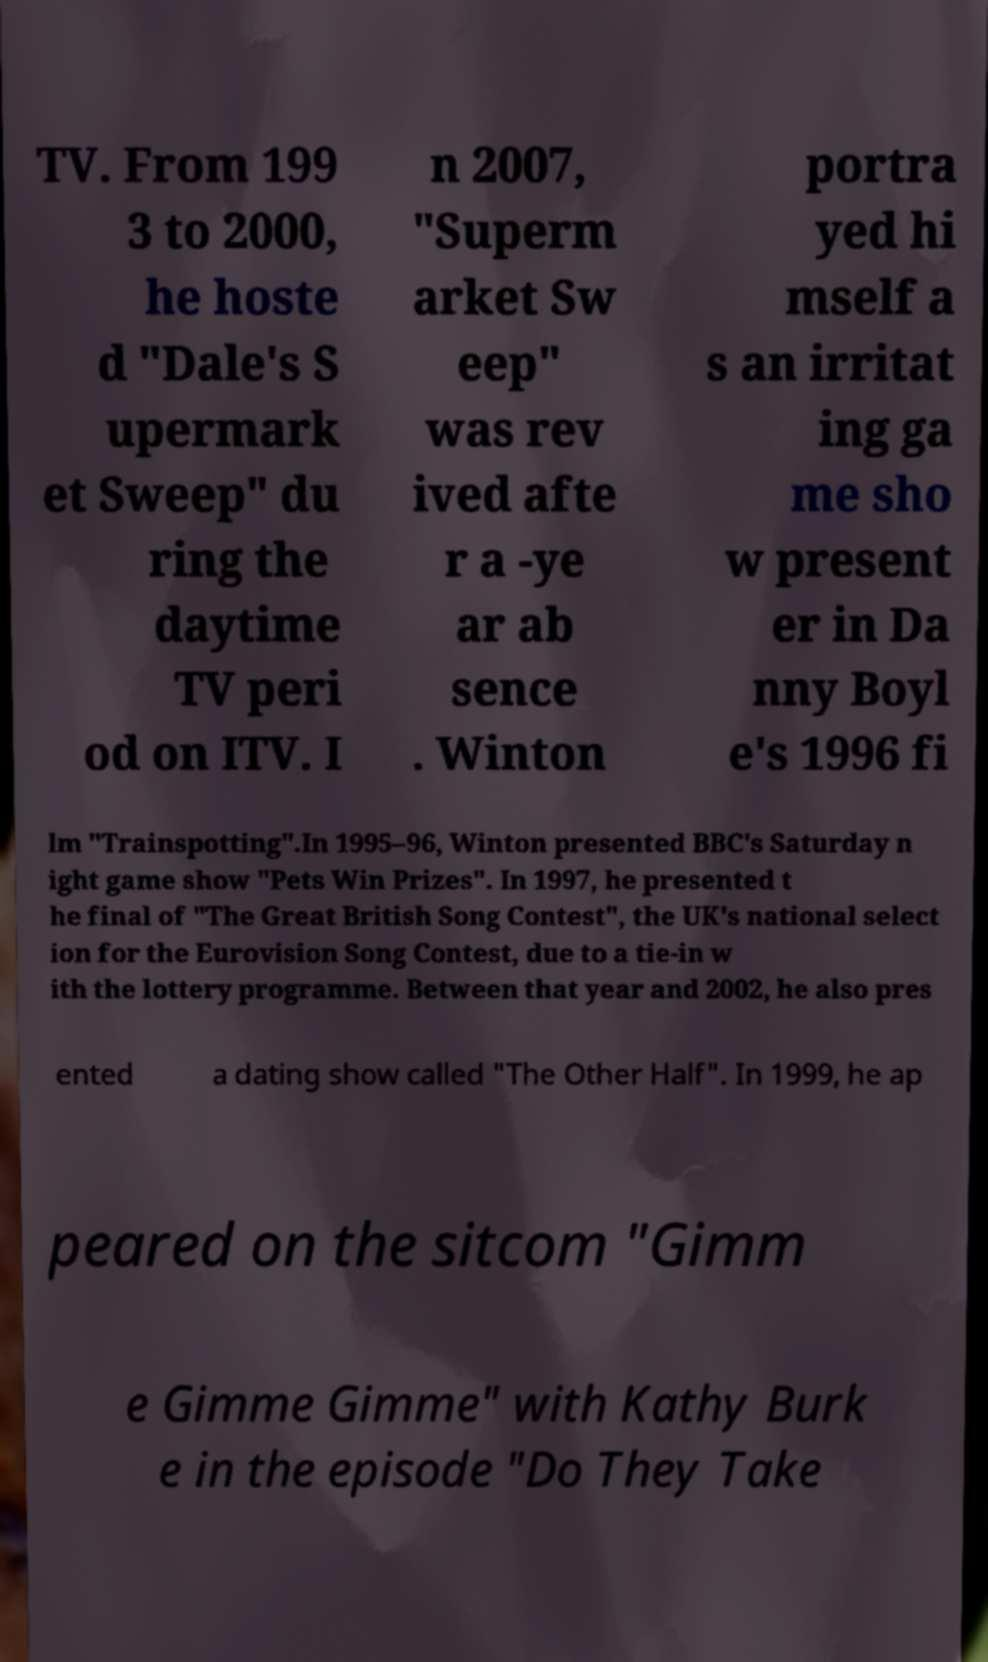Please read and relay the text visible in this image. What does it say? TV. From 199 3 to 2000, he hoste d "Dale's S upermark et Sweep" du ring the daytime TV peri od on ITV. I n 2007, "Superm arket Sw eep" was rev ived afte r a -ye ar ab sence . Winton portra yed hi mself a s an irritat ing ga me sho w present er in Da nny Boyl e's 1996 fi lm "Trainspotting".In 1995–96, Winton presented BBC's Saturday n ight game show "Pets Win Prizes". In 1997, he presented t he final of "The Great British Song Contest", the UK's national select ion for the Eurovision Song Contest, due to a tie-in w ith the lottery programme. Between that year and 2002, he also pres ented a dating show called "The Other Half". In 1999, he ap peared on the sitcom "Gimm e Gimme Gimme" with Kathy Burk e in the episode "Do They Take 